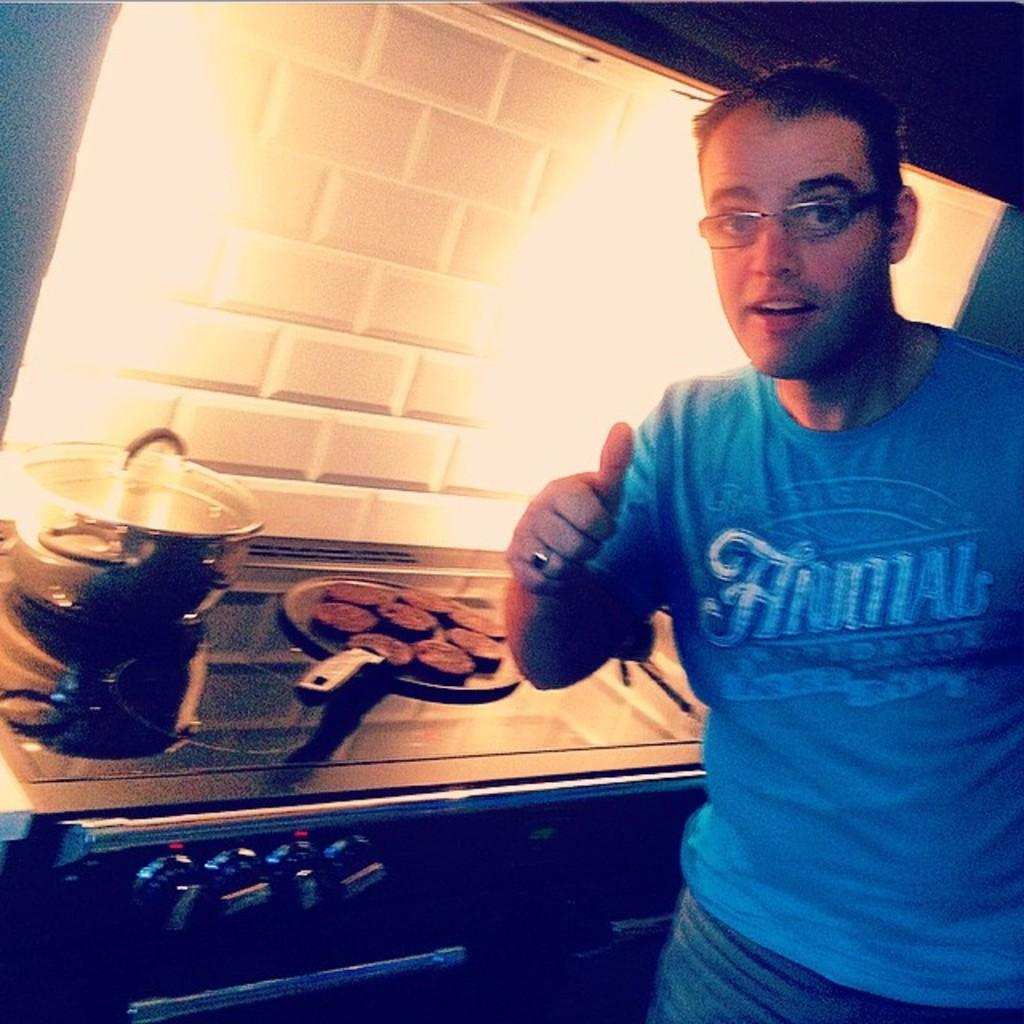<image>
Share a concise interpretation of the image provided. a man wearing a blue shirt that says 'animal' on it 